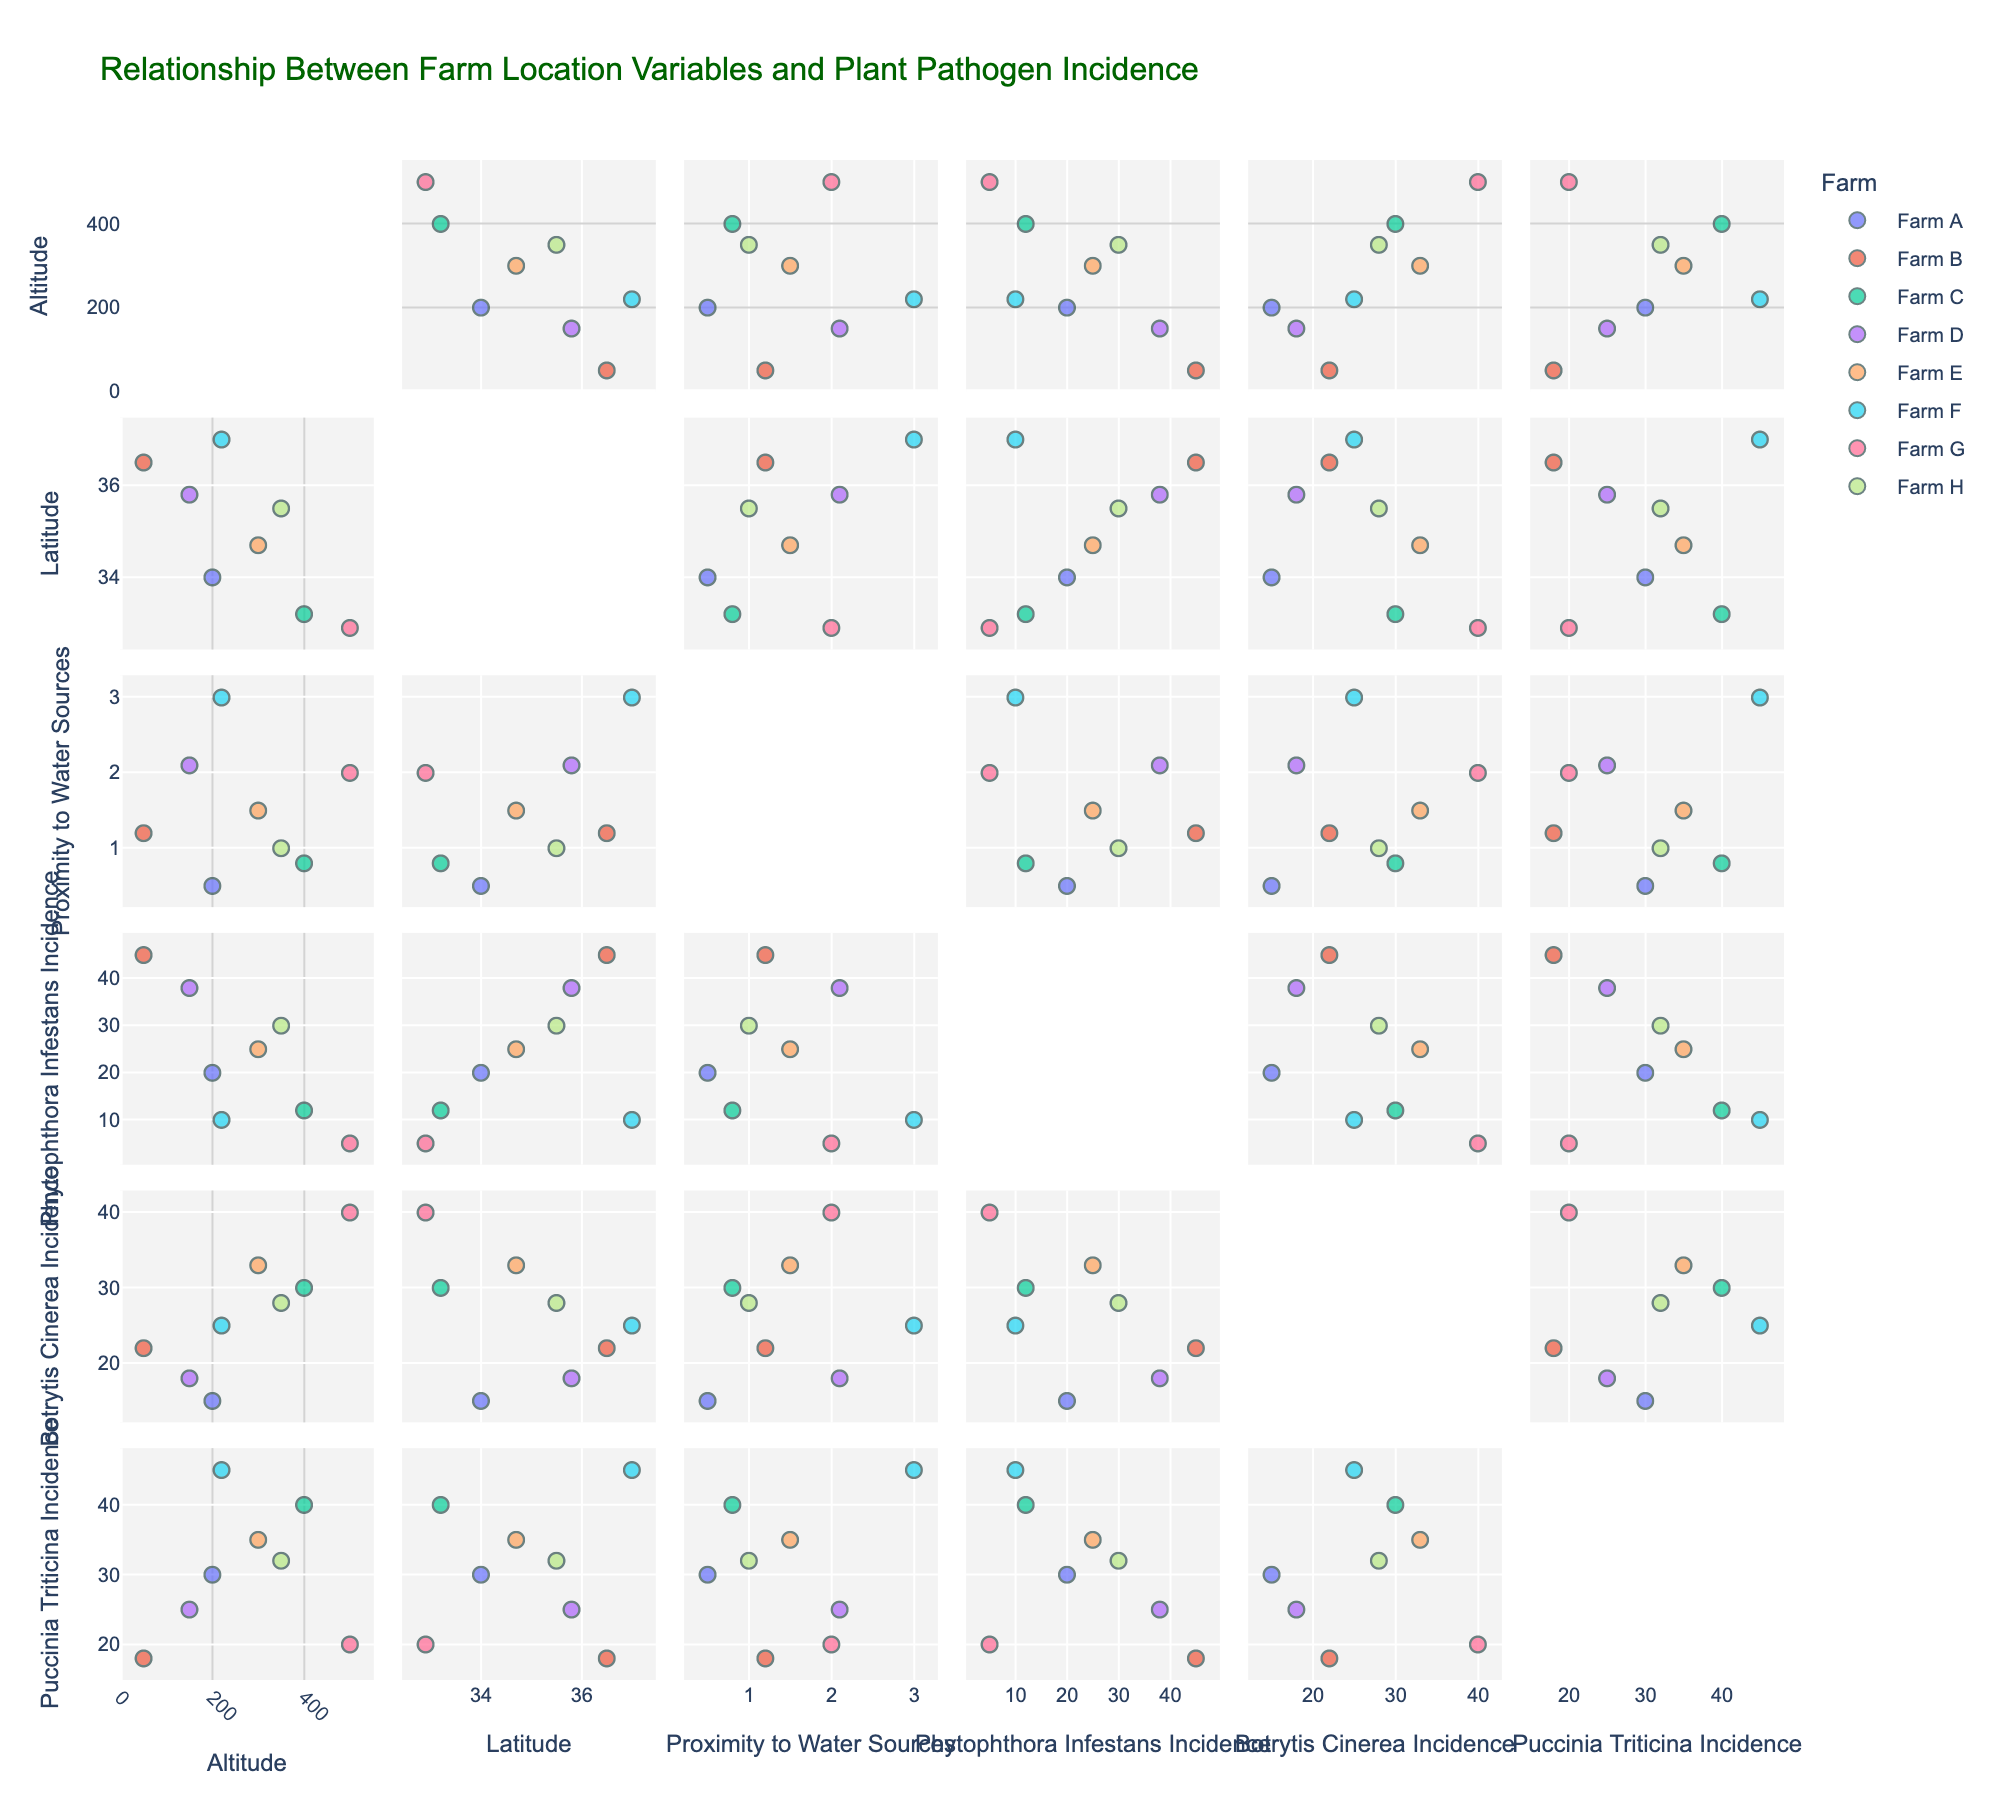How many farms are represented in the scatter plot matrix? There are distinct data points for each farm, identified by different colors. Each farm is labeled distinctly.
Answer: 8 What is the range of altitudes (in meters) covered in the dataset? The chart plots altitude values, and the lowest is 50 meters (Farm B) and the highest is 500 meters (Farm G). Therefore, the range can be calculated as 500 - 50.
Answer: 450 meters Is there a visible trend between altitude and Puccinia Triticina Incidence (%)? By examining the plots where altitude and Puccinia Triticina Incidence (%) are on the x and y axes respectively, or vice versa, we can see if there's an upward or downward trend in these data points. There doesn't appear to be a clear trend.
Answer: No clear trend Which farm has the highest incidence of Botrytis Cinerea? By observing the scatter plot matrix, the maximum incidence of Botrytis Cinerea is sought within the plots involving 'Botrytis Cinerea Incidence (%)'. Farm E has the highest value at 33%.
Answer: Farm E Are farms closer to water sources more likely to have higher incidences of Phytophthora Infestans? Examine the plots where Proximity to Water Sources and Phytophthora Infestans Incidence (%) are plotted against each other. Lower proximity values tend to have higher incidences of Phytophthora Infestans (e.g., Farm G is closest to water and has high incidence).
Answer: Yes How does latitude correlate with altitude? Check the plots where Latitude is plotted against Altitude. There should be an observable trend or lack of one based on the scatter points. It does not appear there is a clear linear relationship.
Answer: No clear correlation Which farm is both high in altitude and close to a water source? Look at the plots that intersect 'Altitude' and 'Proximity to Water Sources'. Farm G is at high altitude (500 m) and close to water (2.0 km).
Answer: Farm G Do farms at higher altitudes show higher incidences of any particular pathogen? Review the plots crossing 'Altitude' with the incidences of each pathogen. There’s no clear indication that higher altitudes consistently lead to higher incidences for any specific pathogen. However, incidences vary.
Answer: No clear evidence What is the average incidence of Puccinia Triticina across all farms? Sum the incidence values of Puccinia Triticina for all farms, then divide by the number of farms (7): (30 + 18 + 40 + 25 + 35 + 45 + 20 + 32) / 8 = 30.63
Answer: 30.63% 